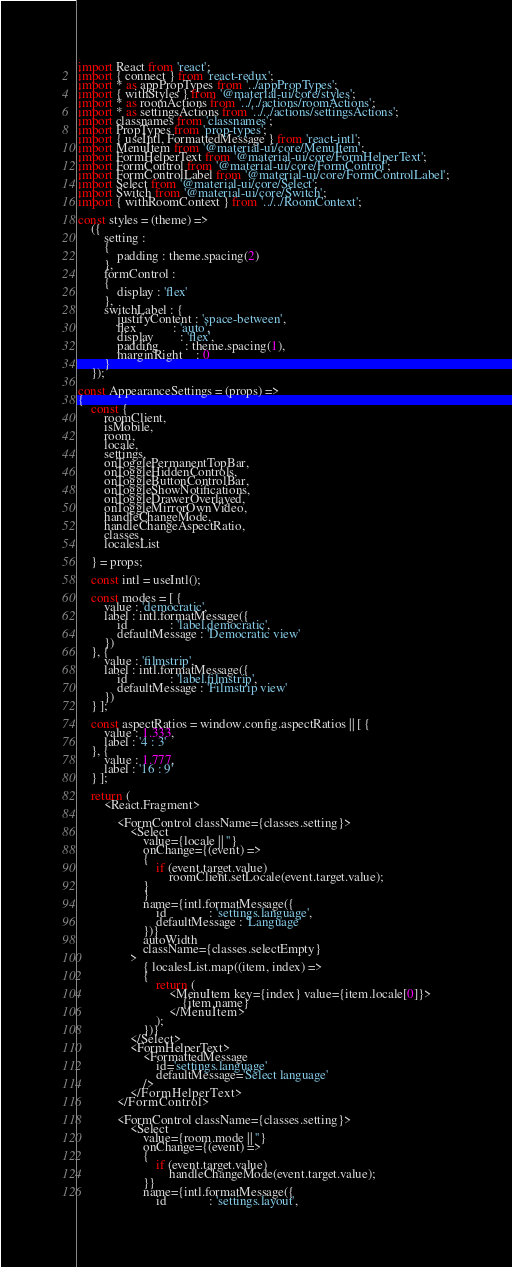<code> <loc_0><loc_0><loc_500><loc_500><_JavaScript_>import React from 'react';
import { connect } from 'react-redux';
import * as appPropTypes from '../appPropTypes';
import { withStyles } from '@material-ui/core/styles';
import * as roomActions from '../../actions/roomActions';
import * as settingsActions from '../../actions/settingsActions';
import classnames from 'classnames';
import PropTypes from 'prop-types';
import { useIntl, FormattedMessage } from 'react-intl';
import MenuItem from '@material-ui/core/MenuItem';
import FormHelperText from '@material-ui/core/FormHelperText';
import FormControl from '@material-ui/core/FormControl';
import FormControlLabel from '@material-ui/core/FormControlLabel';
import Select from '@material-ui/core/Select';
import Switch from '@material-ui/core/Switch';
import { withRoomContext } from '../../RoomContext';

const styles = (theme) =>
	({
		setting :
		{
			padding : theme.spacing(2)
		},
		formControl :
		{
			display : 'flex'
		},
		switchLabel : {
			justifyContent : 'space-between',
			flex           : 'auto',
			display        : 'flex',
			padding        : theme.spacing(1),
			marginRight    : 0
		}
	});

const AppearanceSettings = (props) =>
{
	const {
		roomClient,
		isMobile,
		room,
		locale,
		settings,
		onTogglePermanentTopBar,
		onToggleHiddenControls,
		onToggleButtonControlBar,
		onToggleShowNotifications,
		onToggleDrawerOverlayed,
		onToggleMirrorOwnVideo,
		handleChangeMode,
		handleChangeAspectRatio,
		classes,
		localesList

	} = props;

	const intl = useIntl();

	const modes = [ {
		value : 'democratic',
		label : intl.formatMessage({
			id             : 'label.democratic',
			defaultMessage : 'Democratic view'
		})
	}, {
		value : 'filmstrip',
		label : intl.formatMessage({
			id             : 'label.filmstrip',
			defaultMessage : 'Filmstrip view'
		})
	} ];

	const aspectRatios = window.config.aspectRatios || [ {
		value : 1.333,
		label : '4 : 3'
	}, {
		value : 1.777,
		label : '16 : 9'
	} ];

	return (
		<React.Fragment>

			<FormControl className={classes.setting}>
				<Select
					value={locale || ''}
					onChange={(event) =>
					{
						if (event.target.value)
							roomClient.setLocale(event.target.value);
					}
					}
					name={intl.formatMessage({
						id             : 'settings.language',
						defaultMessage : 'Language'
					})}
					autoWidth
					className={classes.selectEmpty}
				>
					{ localesList.map((item, index) =>
					{
						return (
							<MenuItem key={index} value={item.locale[0]}>
								{item.name}
							</MenuItem>
						);
					})}
				</Select>
				<FormHelperText>
					<FormattedMessage
						id='settings.language'
						defaultMessage='Select language'
					/>
				</FormHelperText>
			</FormControl>

			<FormControl className={classes.setting}>
				<Select
					value={room.mode || ''}
					onChange={(event) =>
					{
						if (event.target.value)
							handleChangeMode(event.target.value);
					}}
					name={intl.formatMessage({
						id             : 'settings.layout',</code> 